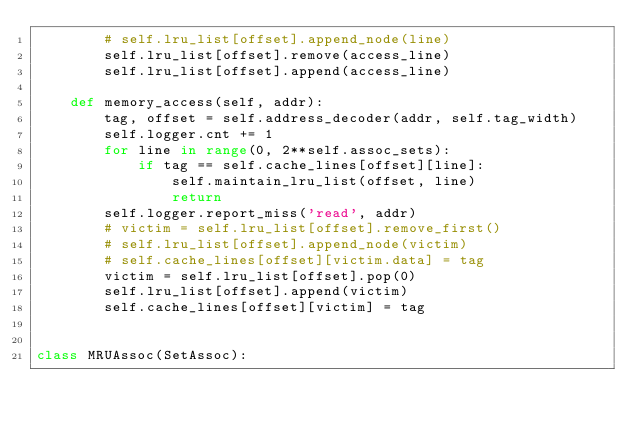Convert code to text. <code><loc_0><loc_0><loc_500><loc_500><_Python_>        # self.lru_list[offset].append_node(line)
        self.lru_list[offset].remove(access_line)
        self.lru_list[offset].append(access_line)

    def memory_access(self, addr):
        tag, offset = self.address_decoder(addr, self.tag_width)
        self.logger.cnt += 1
        for line in range(0, 2**self.assoc_sets):
            if tag == self.cache_lines[offset][line]: 
                self.maintain_lru_list(offset, line)
                return 
        self.logger.report_miss('read', addr)
        # victim = self.lru_list[offset].remove_first()
        # self.lru_list[offset].append_node(victim)
        # self.cache_lines[offset][victim.data] = tag
        victim = self.lru_list[offset].pop(0)
        self.lru_list[offset].append(victim)
        self.cache_lines[offset][victim] = tag


class MRUAssoc(SetAssoc):</code> 